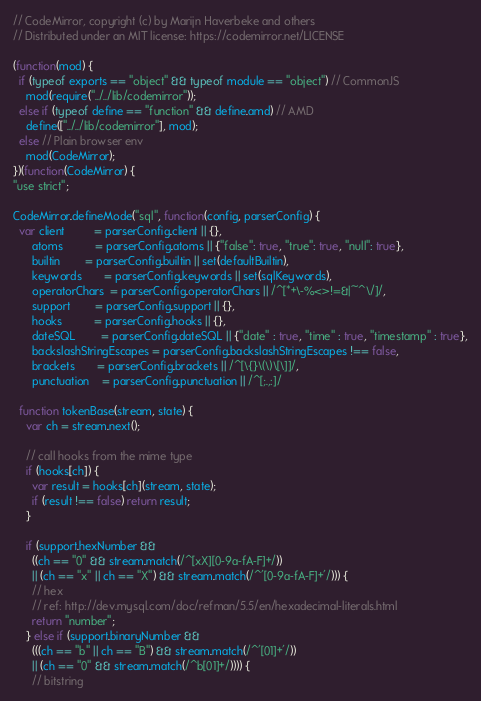<code> <loc_0><loc_0><loc_500><loc_500><_JavaScript_>// CodeMirror, copyright (c) by Marijn Haverbeke and others
// Distributed under an MIT license: https://codemirror.net/LICENSE

(function(mod) {
  if (typeof exports == "object" && typeof module == "object") // CommonJS
    mod(require("../../lib/codemirror"));
  else if (typeof define == "function" && define.amd) // AMD
    define(["../../lib/codemirror"], mod);
  else // Plain browser env
    mod(CodeMirror);
})(function(CodeMirror) {
"use strict";

CodeMirror.defineMode("sql", function(config, parserConfig) {
  var client         = parserConfig.client || {},
      atoms          = parserConfig.atoms || {"false": true, "true": true, "null": true},
      builtin        = parserConfig.builtin || set(defaultBuiltin),
      keywords       = parserConfig.keywords || set(sqlKeywords),
      operatorChars  = parserConfig.operatorChars || /^[*+\-%<>!=&|~^\/]/,
      support        = parserConfig.support || {},
      hooks          = parserConfig.hooks || {},
      dateSQL        = parserConfig.dateSQL || {"date" : true, "time" : true, "timestamp" : true},
      backslashStringEscapes = parserConfig.backslashStringEscapes !== false,
      brackets       = parserConfig.brackets || /^[\{}\(\)\[\]]/,
      punctuation    = parserConfig.punctuation || /^[;.,:]/

  function tokenBase(stream, state) {
    var ch = stream.next();

    // call hooks from the mime type
    if (hooks[ch]) {
      var result = hooks[ch](stream, state);
      if (result !== false) return result;
    }

    if (support.hexNumber &&
      ((ch == "0" && stream.match(/^[xX][0-9a-fA-F]+/))
      || (ch == "x" || ch == "X") && stream.match(/^'[0-9a-fA-F]+'/))) {
      // hex
      // ref: http://dev.mysql.com/doc/refman/5.5/en/hexadecimal-literals.html
      return "number";
    } else if (support.binaryNumber &&
      (((ch == "b" || ch == "B") && stream.match(/^'[01]+'/))
      || (ch == "0" && stream.match(/^b[01]+/)))) {
      // bitstring</code> 